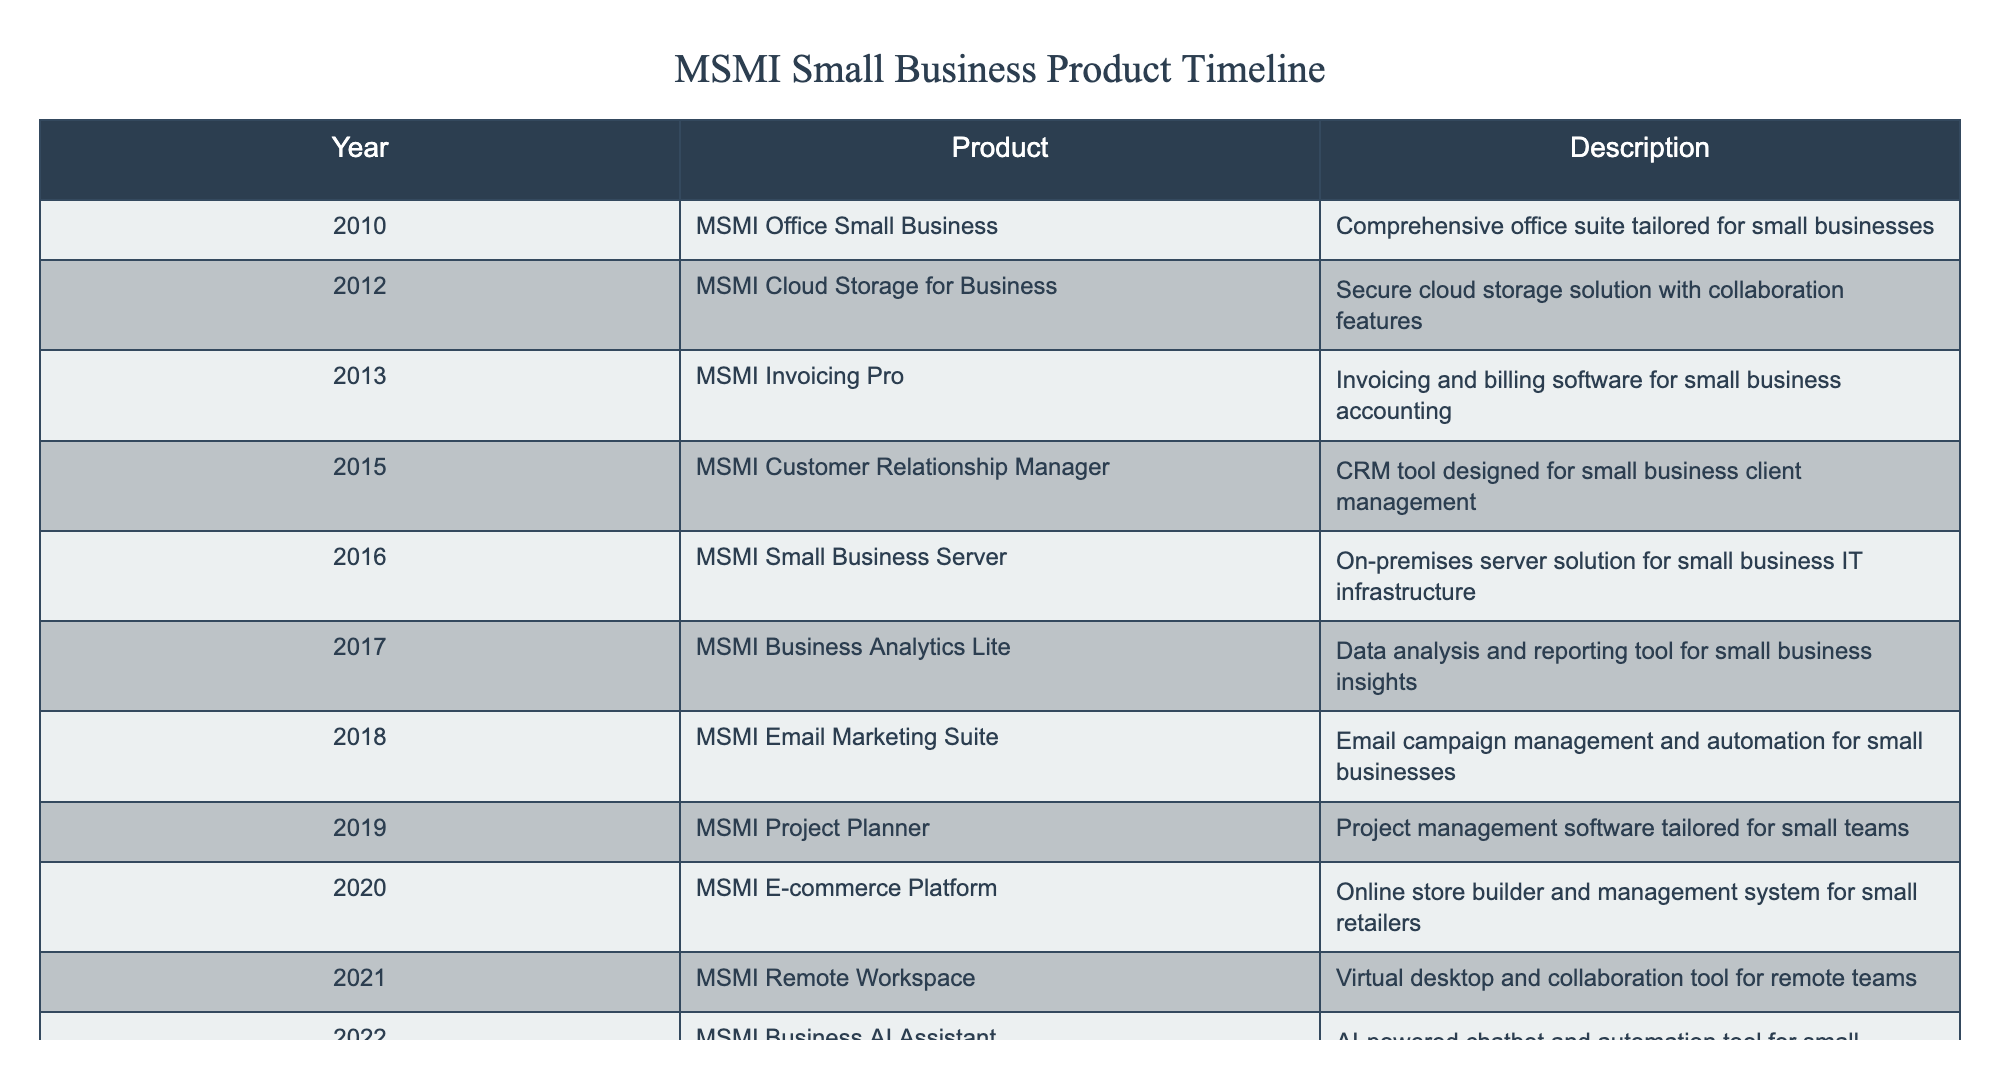What year was MSMI Cloud Storage for Business released? According to the table, MSMI Cloud Storage for Business was listed under the year 2012.
Answer: 2012 What product was launched in 2016? Referring to the table, the product launched in 2016 is MSMI Small Business Server.
Answer: MSMI Small Business Server How many products were released between 2010 and 2015? Checking the product releases from 2010 to 2015, we find six entries: MSMI Office Small Business (2010), MSMI Cloud Storage for Business (2012), MSMI Invoicing Pro (2013), MSMI Customer Relationship Manager (2015), and MSMI Small Business Server (2016), which only includes up to 2015. Hence, there are five products released up to 2015.
Answer: 5 Did MSMI release a remote workspace product before 2021? Looking through the table, MSMI Remote Workspace appears in 2021, which means there were no prior releases of a remote workspace product before that year.
Answer: No What is the total number of products launched after 2018? The products launched after 2018 are MSMI Project Planner (2019), MSMI E-commerce Platform (2020), MSMI Remote Workspace (2021), and MSMI Business AI Assistant (2022), which counts up to four products.
Answer: 4 Which product was specifically designed for small business client management? Based on the table, the product designed for small business client management is MSMI Customer Relationship Manager, released in 2015.
Answer: MSMI Customer Relationship Manager Was there a product related to email marketing released in 2018? Yes, the table shows that MSMI Email Marketing Suite was released in 2018, confirming it was related to email marketing.
Answer: Yes How many more products were released between 2018 and 2022 compared to 2010 and 2015? In the period from 2010 to 2015, there were five products released (as established earlier). From 2018 to 2022, the products released are MSMI Email Marketing Suite (2018), MSMI Project Planner (2019), MSMI E-commerce Platform (2020), MSMI Remote Workspace (2021), and MSMI Business AI Assistant (2022) totaling five as well. Therefore, the difference is zero.
Answer: 0 